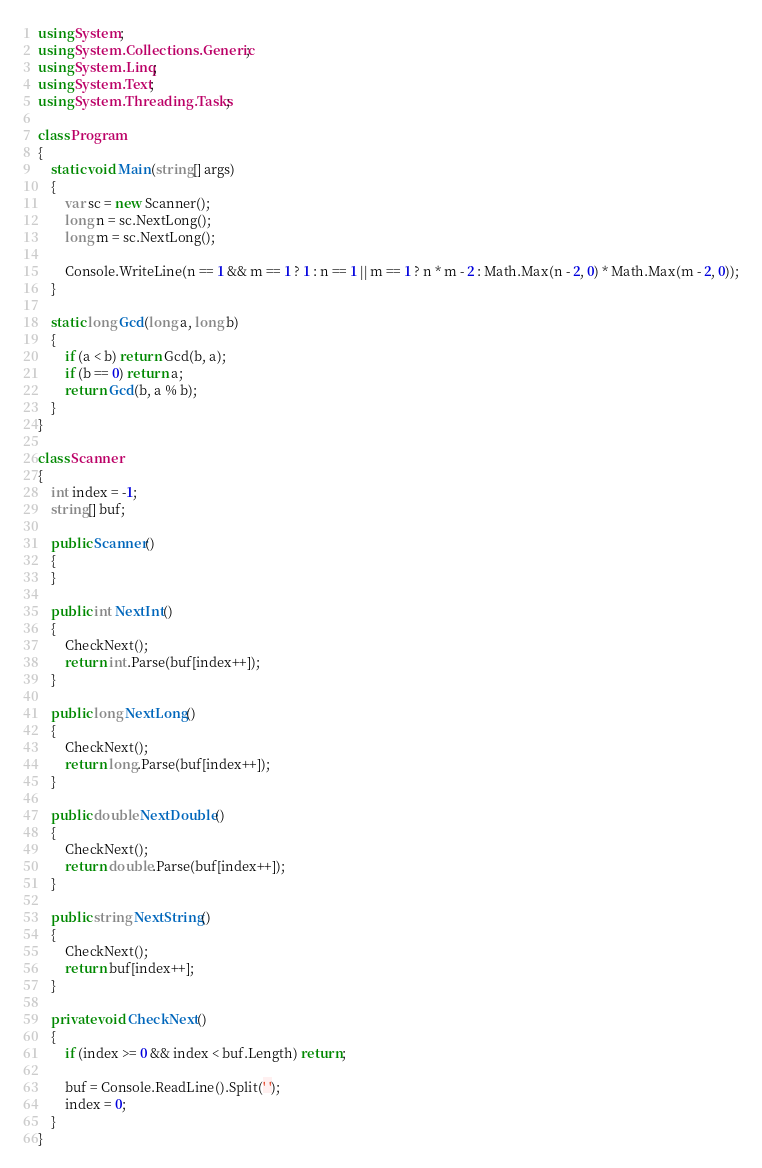<code> <loc_0><loc_0><loc_500><loc_500><_C#_>using System;
using System.Collections.Generic;
using System.Linq;
using System.Text;
using System.Threading.Tasks;

class Program
{
    static void Main(string[] args)
    {
        var sc = new Scanner();
        long n = sc.NextLong();
        long m = sc.NextLong();

        Console.WriteLine(n == 1 && m == 1 ? 1 : n == 1 || m == 1 ? n * m - 2 : Math.Max(n - 2, 0) * Math.Max(m - 2, 0));
    }

    static long Gcd(long a, long b)
    {
        if (a < b) return Gcd(b, a);
        if (b == 0) return a;
        return Gcd(b, a % b);
    }
}

class Scanner
{
    int index = -1;
    string[] buf;

    public Scanner()
    {
    }

    public int NextInt()
    {
        CheckNext();
        return int.Parse(buf[index++]);
    }

    public long NextLong()
    {
        CheckNext();
        return long.Parse(buf[index++]);
    }

    public double NextDouble()
    {
        CheckNext();
        return double.Parse(buf[index++]);
    }

    public string NextString()
    {
        CheckNext();
        return buf[index++];
    }

    private void CheckNext()
    {
        if (index >= 0 && index < buf.Length) return;

        buf = Console.ReadLine().Split(' ');
        index = 0;
    }
}
</code> 